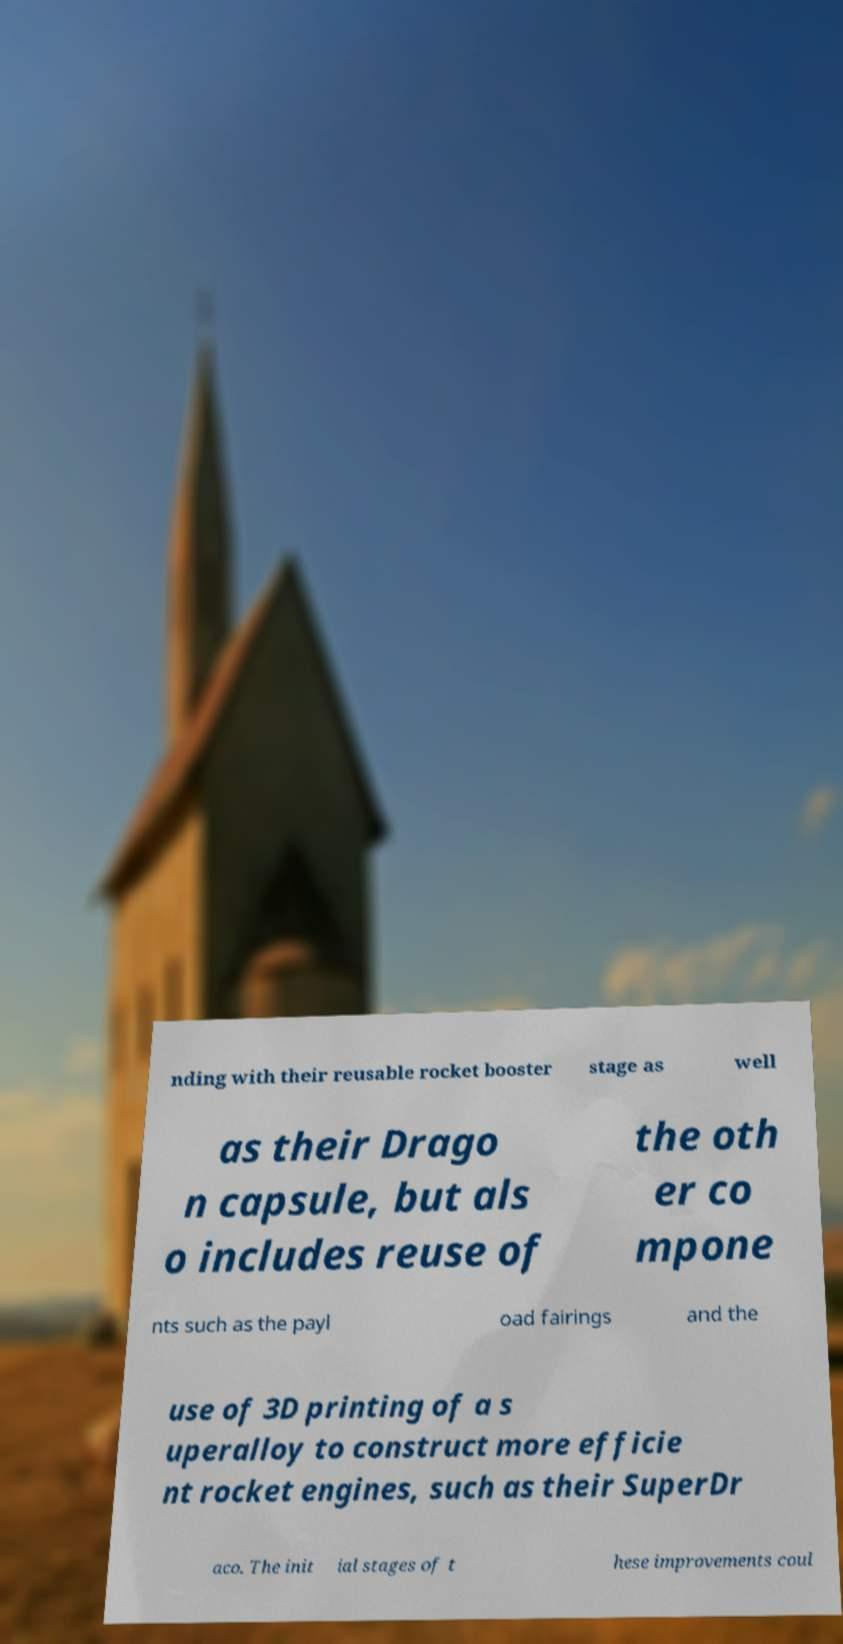Could you assist in decoding the text presented in this image and type it out clearly? nding with their reusable rocket booster stage as well as their Drago n capsule, but als o includes reuse of the oth er co mpone nts such as the payl oad fairings and the use of 3D printing of a s uperalloy to construct more efficie nt rocket engines, such as their SuperDr aco. The init ial stages of t hese improvements coul 